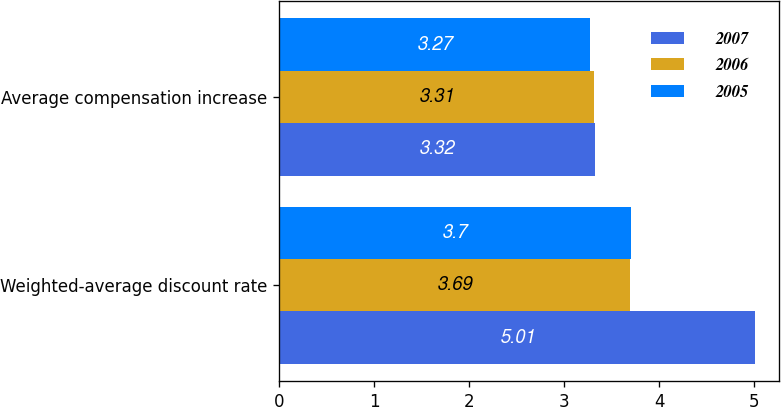Convert chart to OTSL. <chart><loc_0><loc_0><loc_500><loc_500><stacked_bar_chart><ecel><fcel>Weighted-average discount rate<fcel>Average compensation increase<nl><fcel>2007<fcel>5.01<fcel>3.32<nl><fcel>2006<fcel>3.69<fcel>3.31<nl><fcel>2005<fcel>3.7<fcel>3.27<nl></chart> 